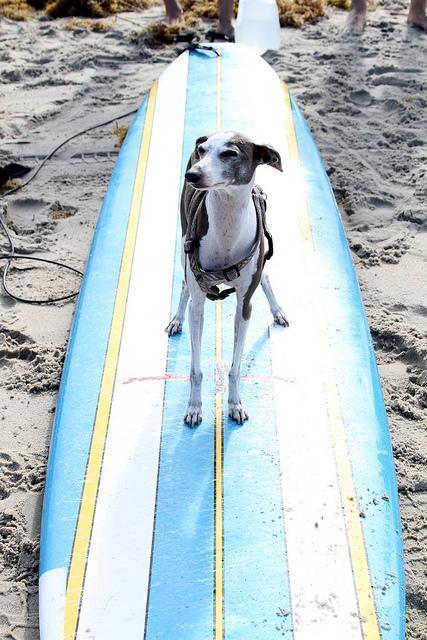How many bikes are in the picture?
Give a very brief answer. 0. 